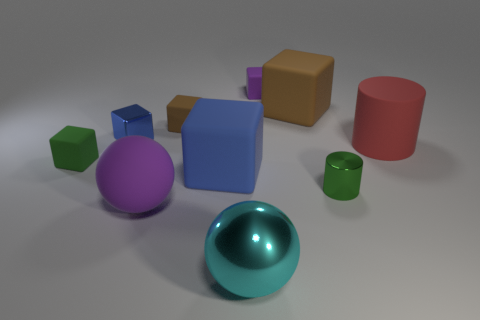Subtract all shiny cubes. How many cubes are left? 5 Subtract all blue balls. How many brown blocks are left? 2 Subtract 2 cubes. How many cubes are left? 4 Subtract all purple blocks. How many blocks are left? 5 Subtract all blue blocks. Subtract all green cylinders. How many blocks are left? 4 Subtract 0 purple cylinders. How many objects are left? 10 Subtract all blocks. How many objects are left? 4 Subtract all cyan rubber spheres. Subtract all green rubber objects. How many objects are left? 9 Add 1 cyan metallic things. How many cyan metallic things are left? 2 Add 1 spheres. How many spheres exist? 3 